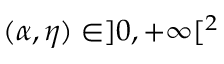Convert formula to latex. <formula><loc_0><loc_0><loc_500><loc_500>( \alpha , \eta ) \in ] 0 , + \infty [ ^ { 2 }</formula> 